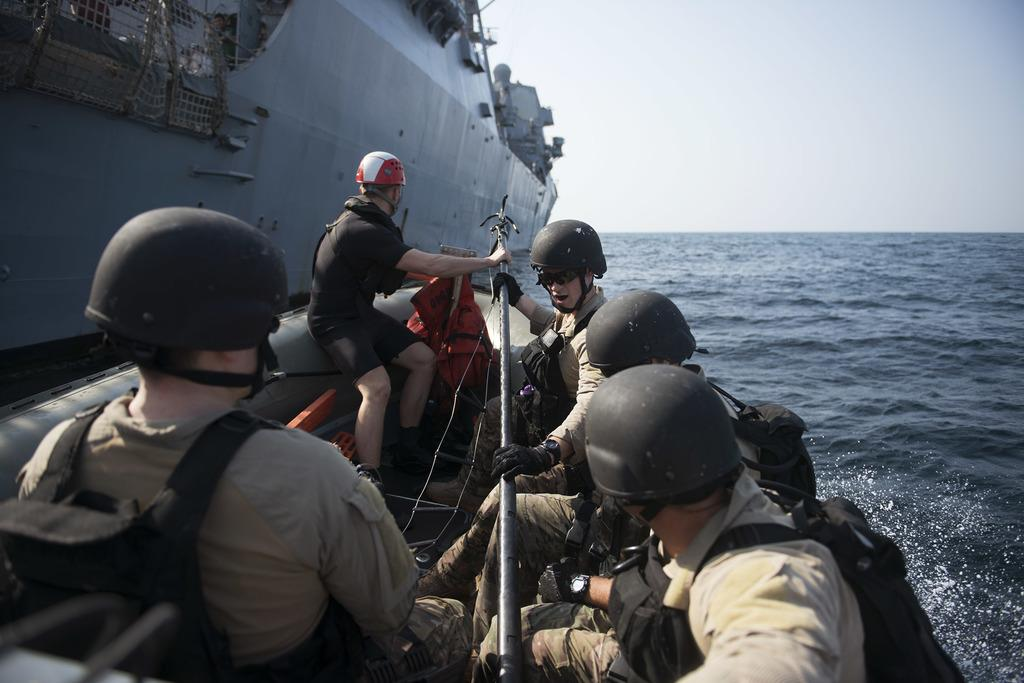What is the main subject of the image? The main subject of the image is a boat. How many people are in the boat? There are multiple persons sitting in the boat. What are the people wearing? The persons are wearing military dresses. What can be seen on the right side of the image? There is water visible on the right side of the image. What is visible at the top of the image? The sky is visible at the top of the image. How many pears are being divided among the soldiers in the image? There are no pears present in the image, and the soldiers are not dividing anything. What type of snakes can be seen slithering in the water near the boat? There are no snakes visible in the image; it only features a boat with people wearing military dresses. 